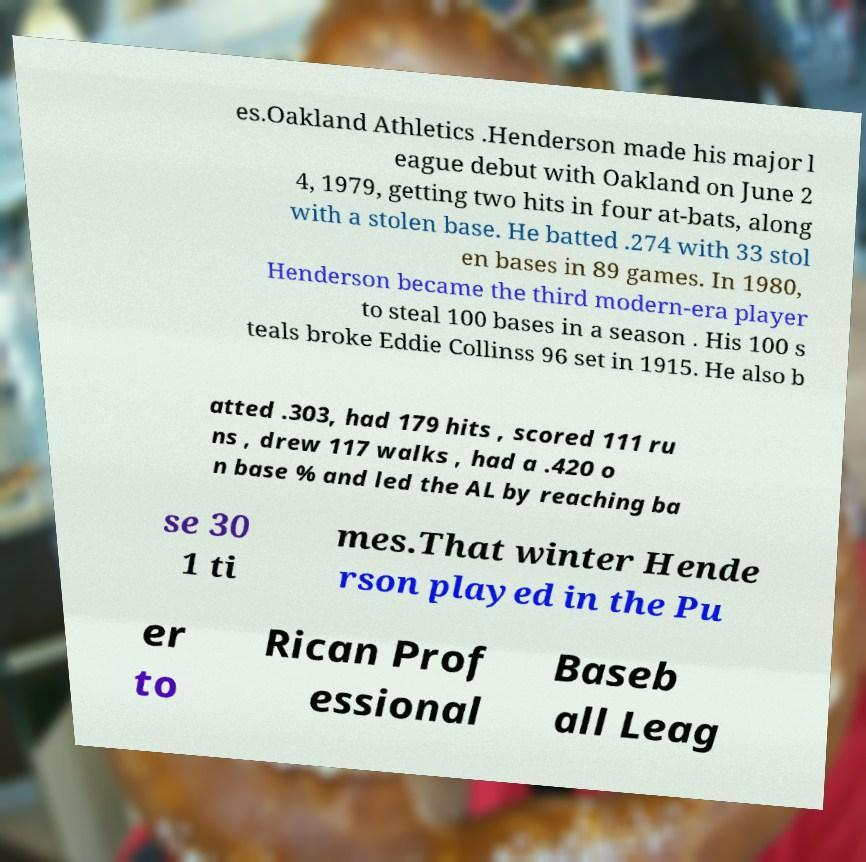What messages or text are displayed in this image? I need them in a readable, typed format. es.Oakland Athletics .Henderson made his major l eague debut with Oakland on June 2 4, 1979, getting two hits in four at-bats, along with a stolen base. He batted .274 with 33 stol en bases in 89 games. In 1980, Henderson became the third modern-era player to steal 100 bases in a season . His 100 s teals broke Eddie Collinss 96 set in 1915. He also b atted .303, had 179 hits , scored 111 ru ns , drew 117 walks , had a .420 o n base % and led the AL by reaching ba se 30 1 ti mes.That winter Hende rson played in the Pu er to Rican Prof essional Baseb all Leag 